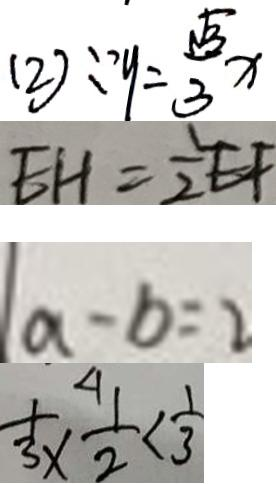Convert formula to latex. <formula><loc_0><loc_0><loc_500><loc_500>( 2 ) \because y = \frac { \sqrt { 3 } } { 3 } x 
 E H = \frac { 1 } { 2 } E F 
 a - b = 2 
 \frac { 1 } { 3 } \times \frac { 1 } { 2 } < \frac { 1 } { 3 }</formula> 